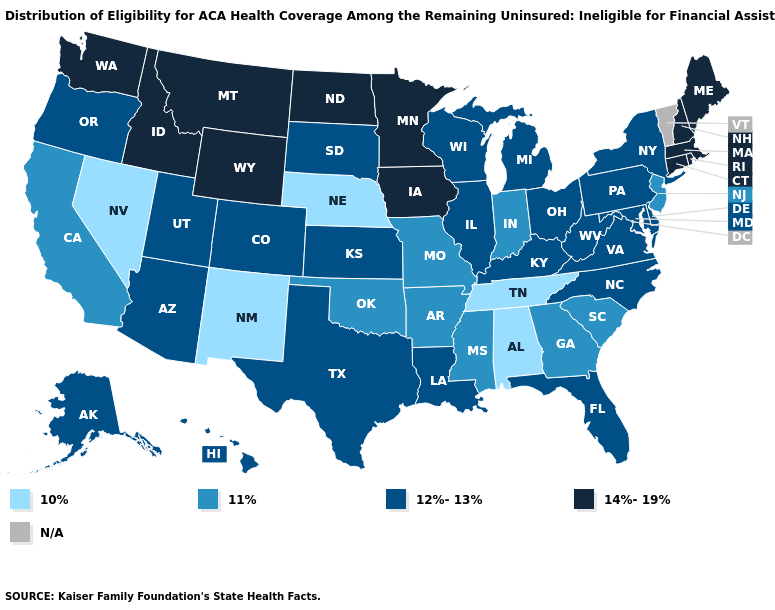Among the states that border Arkansas , which have the highest value?
Write a very short answer. Louisiana, Texas. Does the map have missing data?
Short answer required. Yes. Among the states that border Oklahoma , does Texas have the highest value?
Give a very brief answer. Yes. What is the value of Kansas?
Short answer required. 12%-13%. Among the states that border Arizona , which have the lowest value?
Concise answer only. Nevada, New Mexico. What is the value of Alabama?
Be succinct. 10%. Name the states that have a value in the range N/A?
Keep it brief. Vermont. Name the states that have a value in the range 10%?
Be succinct. Alabama, Nebraska, Nevada, New Mexico, Tennessee. Which states have the lowest value in the USA?
Write a very short answer. Alabama, Nebraska, Nevada, New Mexico, Tennessee. Name the states that have a value in the range 11%?
Be succinct. Arkansas, California, Georgia, Indiana, Mississippi, Missouri, New Jersey, Oklahoma, South Carolina. What is the lowest value in states that border Indiana?
Short answer required. 12%-13%. Among the states that border Montana , does Wyoming have the lowest value?
Keep it brief. No. Does the first symbol in the legend represent the smallest category?
Quick response, please. Yes. 